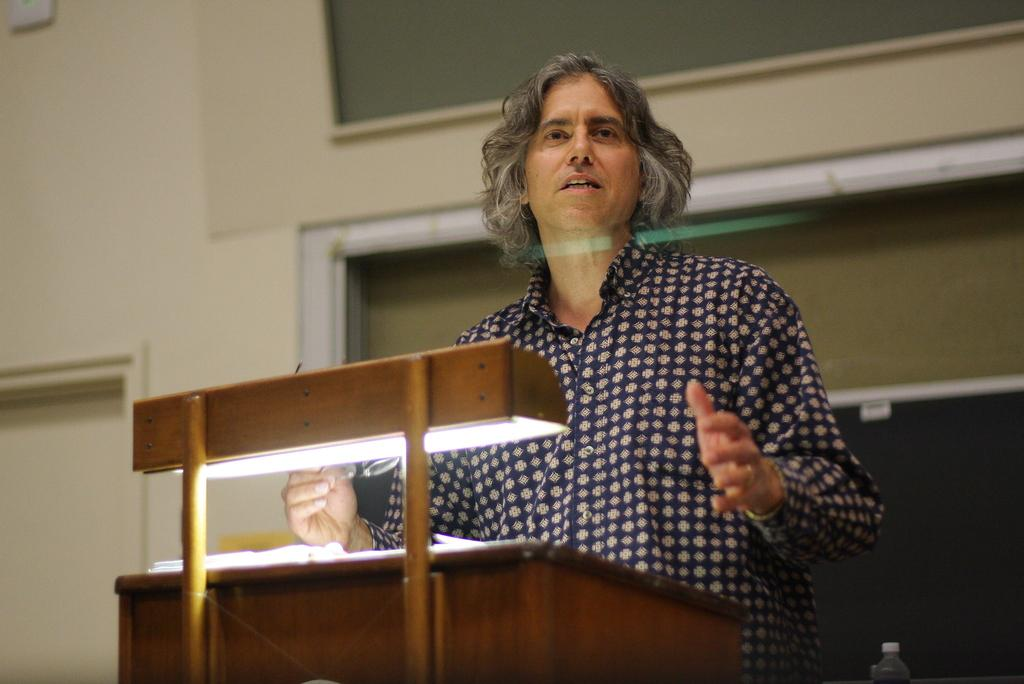What is the main subject of the image? There is a person in the image. Can you describe the person's attire? The person is wearing clothes. What can be seen behind the person in the image? The person is standing in front of a podium. What type of ghost can be seen interacting with the railway in the image? There is no ghost or railway present in the image; it features a person standing in front of a podium. 